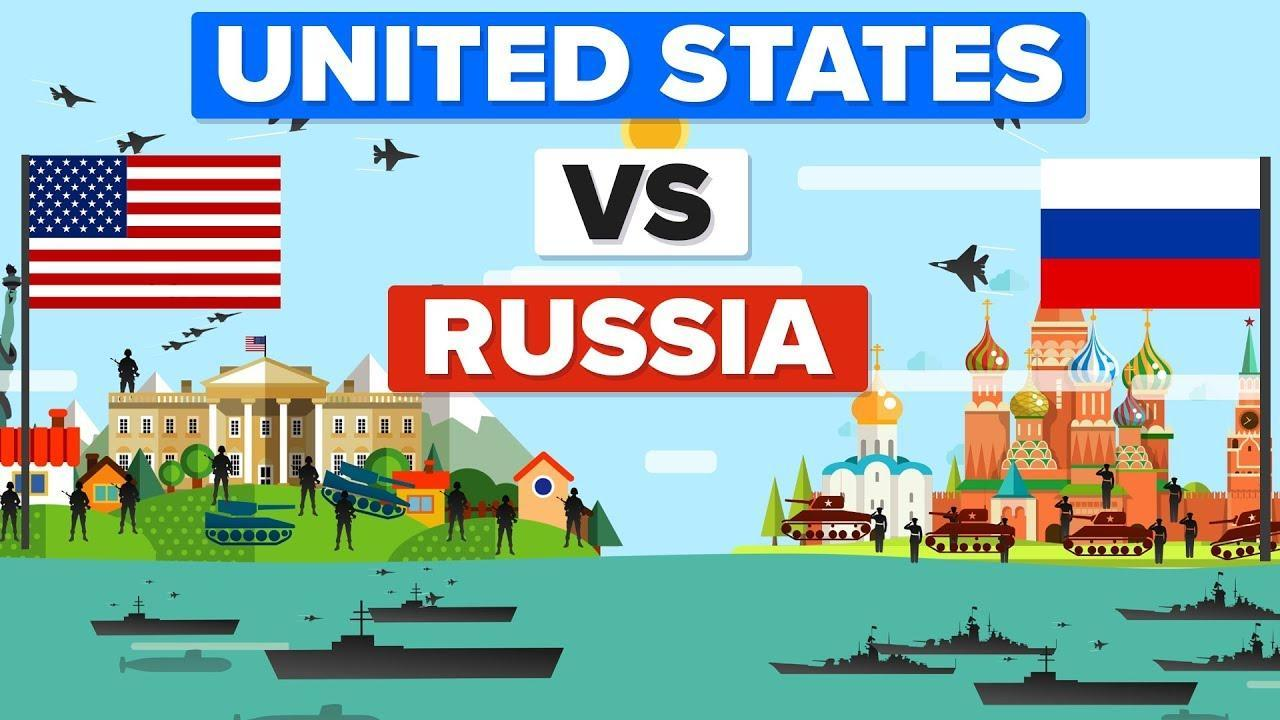How many soldiers are present in the Russian army?
Answer the question with a short phrase. 9 How many soldiers are there in the American army? 10 